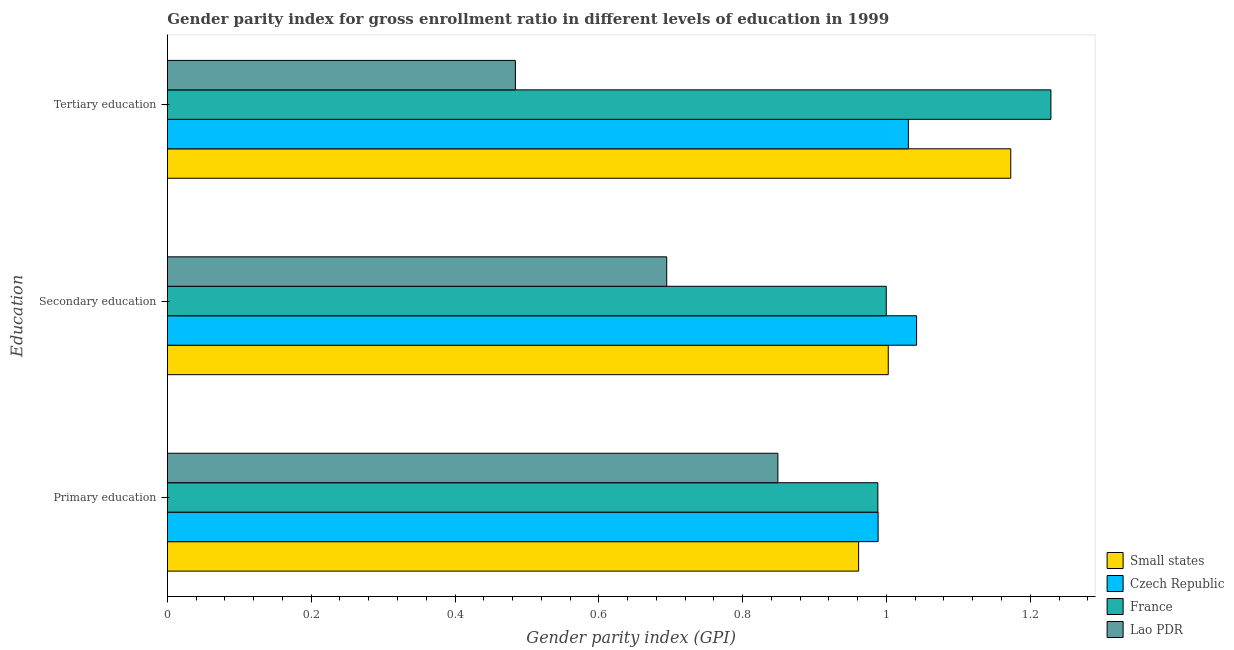Are the number of bars on each tick of the Y-axis equal?
Provide a succinct answer. Yes. What is the label of the 1st group of bars from the top?
Your answer should be compact. Tertiary education. What is the gender parity index in secondary education in Lao PDR?
Offer a very short reply. 0.69. Across all countries, what is the maximum gender parity index in primary education?
Offer a very short reply. 0.99. Across all countries, what is the minimum gender parity index in tertiary education?
Offer a very short reply. 0.48. In which country was the gender parity index in secondary education maximum?
Make the answer very short. Czech Republic. In which country was the gender parity index in secondary education minimum?
Keep it short and to the point. Lao PDR. What is the total gender parity index in tertiary education in the graph?
Give a very brief answer. 3.92. What is the difference between the gender parity index in tertiary education in Czech Republic and that in France?
Keep it short and to the point. -0.2. What is the difference between the gender parity index in primary education in Small states and the gender parity index in secondary education in France?
Give a very brief answer. -0.04. What is the average gender parity index in tertiary education per country?
Offer a very short reply. 0.98. What is the difference between the gender parity index in secondary education and gender parity index in primary education in Small states?
Give a very brief answer. 0.04. What is the ratio of the gender parity index in tertiary education in Czech Republic to that in France?
Provide a short and direct response. 0.84. Is the gender parity index in tertiary education in France less than that in Small states?
Your response must be concise. No. Is the difference between the gender parity index in tertiary education in France and Czech Republic greater than the difference between the gender parity index in primary education in France and Czech Republic?
Your response must be concise. Yes. What is the difference between the highest and the second highest gender parity index in primary education?
Provide a succinct answer. 0. What is the difference between the highest and the lowest gender parity index in secondary education?
Provide a short and direct response. 0.35. What does the 1st bar from the top in Secondary education represents?
Offer a terse response. Lao PDR. What does the 4th bar from the bottom in Tertiary education represents?
Offer a terse response. Lao PDR. Is it the case that in every country, the sum of the gender parity index in primary education and gender parity index in secondary education is greater than the gender parity index in tertiary education?
Offer a terse response. Yes. How many bars are there?
Ensure brevity in your answer.  12. How many countries are there in the graph?
Your answer should be very brief. 4. Are the values on the major ticks of X-axis written in scientific E-notation?
Make the answer very short. No. Does the graph contain grids?
Make the answer very short. No. How many legend labels are there?
Make the answer very short. 4. How are the legend labels stacked?
Keep it short and to the point. Vertical. What is the title of the graph?
Your answer should be compact. Gender parity index for gross enrollment ratio in different levels of education in 1999. What is the label or title of the X-axis?
Provide a succinct answer. Gender parity index (GPI). What is the label or title of the Y-axis?
Offer a very short reply. Education. What is the Gender parity index (GPI) in Small states in Primary education?
Your answer should be very brief. 0.96. What is the Gender parity index (GPI) in Czech Republic in Primary education?
Keep it short and to the point. 0.99. What is the Gender parity index (GPI) in France in Primary education?
Make the answer very short. 0.99. What is the Gender parity index (GPI) of Lao PDR in Primary education?
Provide a short and direct response. 0.85. What is the Gender parity index (GPI) of Small states in Secondary education?
Provide a short and direct response. 1. What is the Gender parity index (GPI) of Czech Republic in Secondary education?
Give a very brief answer. 1.04. What is the Gender parity index (GPI) of France in Secondary education?
Your response must be concise. 1. What is the Gender parity index (GPI) in Lao PDR in Secondary education?
Offer a terse response. 0.69. What is the Gender parity index (GPI) in Small states in Tertiary education?
Offer a very short reply. 1.17. What is the Gender parity index (GPI) of Czech Republic in Tertiary education?
Give a very brief answer. 1.03. What is the Gender parity index (GPI) of France in Tertiary education?
Offer a very short reply. 1.23. What is the Gender parity index (GPI) of Lao PDR in Tertiary education?
Keep it short and to the point. 0.48. Across all Education, what is the maximum Gender parity index (GPI) of Small states?
Keep it short and to the point. 1.17. Across all Education, what is the maximum Gender parity index (GPI) of Czech Republic?
Make the answer very short. 1.04. Across all Education, what is the maximum Gender parity index (GPI) in France?
Provide a succinct answer. 1.23. Across all Education, what is the maximum Gender parity index (GPI) of Lao PDR?
Your answer should be compact. 0.85. Across all Education, what is the minimum Gender parity index (GPI) of Small states?
Your answer should be very brief. 0.96. Across all Education, what is the minimum Gender parity index (GPI) of Czech Republic?
Keep it short and to the point. 0.99. Across all Education, what is the minimum Gender parity index (GPI) in France?
Provide a short and direct response. 0.99. Across all Education, what is the minimum Gender parity index (GPI) of Lao PDR?
Keep it short and to the point. 0.48. What is the total Gender parity index (GPI) of Small states in the graph?
Provide a short and direct response. 3.14. What is the total Gender parity index (GPI) in Czech Republic in the graph?
Ensure brevity in your answer.  3.06. What is the total Gender parity index (GPI) in France in the graph?
Make the answer very short. 3.22. What is the total Gender parity index (GPI) in Lao PDR in the graph?
Your response must be concise. 2.03. What is the difference between the Gender parity index (GPI) in Small states in Primary education and that in Secondary education?
Keep it short and to the point. -0.04. What is the difference between the Gender parity index (GPI) of Czech Republic in Primary education and that in Secondary education?
Make the answer very short. -0.05. What is the difference between the Gender parity index (GPI) in France in Primary education and that in Secondary education?
Ensure brevity in your answer.  -0.01. What is the difference between the Gender parity index (GPI) of Lao PDR in Primary education and that in Secondary education?
Make the answer very short. 0.15. What is the difference between the Gender parity index (GPI) in Small states in Primary education and that in Tertiary education?
Provide a short and direct response. -0.21. What is the difference between the Gender parity index (GPI) of Czech Republic in Primary education and that in Tertiary education?
Offer a terse response. -0.04. What is the difference between the Gender parity index (GPI) in France in Primary education and that in Tertiary education?
Make the answer very short. -0.24. What is the difference between the Gender parity index (GPI) of Lao PDR in Primary education and that in Tertiary education?
Provide a succinct answer. 0.36. What is the difference between the Gender parity index (GPI) in Small states in Secondary education and that in Tertiary education?
Keep it short and to the point. -0.17. What is the difference between the Gender parity index (GPI) of Czech Republic in Secondary education and that in Tertiary education?
Give a very brief answer. 0.01. What is the difference between the Gender parity index (GPI) of France in Secondary education and that in Tertiary education?
Make the answer very short. -0.23. What is the difference between the Gender parity index (GPI) in Lao PDR in Secondary education and that in Tertiary education?
Ensure brevity in your answer.  0.21. What is the difference between the Gender parity index (GPI) in Small states in Primary education and the Gender parity index (GPI) in Czech Republic in Secondary education?
Your answer should be compact. -0.08. What is the difference between the Gender parity index (GPI) of Small states in Primary education and the Gender parity index (GPI) of France in Secondary education?
Keep it short and to the point. -0.04. What is the difference between the Gender parity index (GPI) in Small states in Primary education and the Gender parity index (GPI) in Lao PDR in Secondary education?
Offer a very short reply. 0.27. What is the difference between the Gender parity index (GPI) in Czech Republic in Primary education and the Gender parity index (GPI) in France in Secondary education?
Your response must be concise. -0.01. What is the difference between the Gender parity index (GPI) in Czech Republic in Primary education and the Gender parity index (GPI) in Lao PDR in Secondary education?
Give a very brief answer. 0.29. What is the difference between the Gender parity index (GPI) in France in Primary education and the Gender parity index (GPI) in Lao PDR in Secondary education?
Provide a short and direct response. 0.29. What is the difference between the Gender parity index (GPI) in Small states in Primary education and the Gender parity index (GPI) in Czech Republic in Tertiary education?
Offer a very short reply. -0.07. What is the difference between the Gender parity index (GPI) of Small states in Primary education and the Gender parity index (GPI) of France in Tertiary education?
Make the answer very short. -0.27. What is the difference between the Gender parity index (GPI) of Small states in Primary education and the Gender parity index (GPI) of Lao PDR in Tertiary education?
Keep it short and to the point. 0.48. What is the difference between the Gender parity index (GPI) of Czech Republic in Primary education and the Gender parity index (GPI) of France in Tertiary education?
Keep it short and to the point. -0.24. What is the difference between the Gender parity index (GPI) of Czech Republic in Primary education and the Gender parity index (GPI) of Lao PDR in Tertiary education?
Make the answer very short. 0.5. What is the difference between the Gender parity index (GPI) of France in Primary education and the Gender parity index (GPI) of Lao PDR in Tertiary education?
Give a very brief answer. 0.5. What is the difference between the Gender parity index (GPI) in Small states in Secondary education and the Gender parity index (GPI) in Czech Republic in Tertiary education?
Offer a very short reply. -0.03. What is the difference between the Gender parity index (GPI) in Small states in Secondary education and the Gender parity index (GPI) in France in Tertiary education?
Your answer should be very brief. -0.23. What is the difference between the Gender parity index (GPI) in Small states in Secondary education and the Gender parity index (GPI) in Lao PDR in Tertiary education?
Make the answer very short. 0.52. What is the difference between the Gender parity index (GPI) of Czech Republic in Secondary education and the Gender parity index (GPI) of France in Tertiary education?
Offer a very short reply. -0.19. What is the difference between the Gender parity index (GPI) of Czech Republic in Secondary education and the Gender parity index (GPI) of Lao PDR in Tertiary education?
Ensure brevity in your answer.  0.56. What is the difference between the Gender parity index (GPI) in France in Secondary education and the Gender parity index (GPI) in Lao PDR in Tertiary education?
Provide a short and direct response. 0.52. What is the average Gender parity index (GPI) in Small states per Education?
Provide a short and direct response. 1.05. What is the average Gender parity index (GPI) of Czech Republic per Education?
Your answer should be very brief. 1.02. What is the average Gender parity index (GPI) in France per Education?
Keep it short and to the point. 1.07. What is the average Gender parity index (GPI) in Lao PDR per Education?
Ensure brevity in your answer.  0.68. What is the difference between the Gender parity index (GPI) of Small states and Gender parity index (GPI) of Czech Republic in Primary education?
Ensure brevity in your answer.  -0.03. What is the difference between the Gender parity index (GPI) of Small states and Gender parity index (GPI) of France in Primary education?
Offer a terse response. -0.03. What is the difference between the Gender parity index (GPI) of Small states and Gender parity index (GPI) of Lao PDR in Primary education?
Offer a terse response. 0.11. What is the difference between the Gender parity index (GPI) in Czech Republic and Gender parity index (GPI) in Lao PDR in Primary education?
Ensure brevity in your answer.  0.14. What is the difference between the Gender parity index (GPI) of France and Gender parity index (GPI) of Lao PDR in Primary education?
Your response must be concise. 0.14. What is the difference between the Gender parity index (GPI) in Small states and Gender parity index (GPI) in Czech Republic in Secondary education?
Offer a very short reply. -0.04. What is the difference between the Gender parity index (GPI) of Small states and Gender parity index (GPI) of France in Secondary education?
Make the answer very short. 0. What is the difference between the Gender parity index (GPI) of Small states and Gender parity index (GPI) of Lao PDR in Secondary education?
Offer a terse response. 0.31. What is the difference between the Gender parity index (GPI) in Czech Republic and Gender parity index (GPI) in France in Secondary education?
Make the answer very short. 0.04. What is the difference between the Gender parity index (GPI) in Czech Republic and Gender parity index (GPI) in Lao PDR in Secondary education?
Offer a very short reply. 0.35. What is the difference between the Gender parity index (GPI) of France and Gender parity index (GPI) of Lao PDR in Secondary education?
Provide a succinct answer. 0.31. What is the difference between the Gender parity index (GPI) of Small states and Gender parity index (GPI) of Czech Republic in Tertiary education?
Provide a short and direct response. 0.14. What is the difference between the Gender parity index (GPI) of Small states and Gender parity index (GPI) of France in Tertiary education?
Ensure brevity in your answer.  -0.06. What is the difference between the Gender parity index (GPI) of Small states and Gender parity index (GPI) of Lao PDR in Tertiary education?
Your response must be concise. 0.69. What is the difference between the Gender parity index (GPI) in Czech Republic and Gender parity index (GPI) in France in Tertiary education?
Offer a terse response. -0.2. What is the difference between the Gender parity index (GPI) in Czech Republic and Gender parity index (GPI) in Lao PDR in Tertiary education?
Offer a very short reply. 0.55. What is the difference between the Gender parity index (GPI) in France and Gender parity index (GPI) in Lao PDR in Tertiary education?
Provide a short and direct response. 0.74. What is the ratio of the Gender parity index (GPI) of Small states in Primary education to that in Secondary education?
Provide a succinct answer. 0.96. What is the ratio of the Gender parity index (GPI) in Czech Republic in Primary education to that in Secondary education?
Make the answer very short. 0.95. What is the ratio of the Gender parity index (GPI) of France in Primary education to that in Secondary education?
Offer a very short reply. 0.99. What is the ratio of the Gender parity index (GPI) in Lao PDR in Primary education to that in Secondary education?
Ensure brevity in your answer.  1.22. What is the ratio of the Gender parity index (GPI) in Small states in Primary education to that in Tertiary education?
Offer a very short reply. 0.82. What is the ratio of the Gender parity index (GPI) in Czech Republic in Primary education to that in Tertiary education?
Your response must be concise. 0.96. What is the ratio of the Gender parity index (GPI) in France in Primary education to that in Tertiary education?
Ensure brevity in your answer.  0.8. What is the ratio of the Gender parity index (GPI) of Lao PDR in Primary education to that in Tertiary education?
Offer a terse response. 1.75. What is the ratio of the Gender parity index (GPI) of Small states in Secondary education to that in Tertiary education?
Offer a very short reply. 0.85. What is the ratio of the Gender parity index (GPI) in Czech Republic in Secondary education to that in Tertiary education?
Your answer should be compact. 1.01. What is the ratio of the Gender parity index (GPI) of France in Secondary education to that in Tertiary education?
Keep it short and to the point. 0.81. What is the ratio of the Gender parity index (GPI) of Lao PDR in Secondary education to that in Tertiary education?
Your answer should be very brief. 1.43. What is the difference between the highest and the second highest Gender parity index (GPI) in Small states?
Provide a short and direct response. 0.17. What is the difference between the highest and the second highest Gender parity index (GPI) in Czech Republic?
Your answer should be compact. 0.01. What is the difference between the highest and the second highest Gender parity index (GPI) of France?
Your answer should be compact. 0.23. What is the difference between the highest and the second highest Gender parity index (GPI) in Lao PDR?
Keep it short and to the point. 0.15. What is the difference between the highest and the lowest Gender parity index (GPI) of Small states?
Ensure brevity in your answer.  0.21. What is the difference between the highest and the lowest Gender parity index (GPI) of Czech Republic?
Give a very brief answer. 0.05. What is the difference between the highest and the lowest Gender parity index (GPI) of France?
Offer a very short reply. 0.24. What is the difference between the highest and the lowest Gender parity index (GPI) in Lao PDR?
Keep it short and to the point. 0.36. 